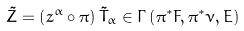<formula> <loc_0><loc_0><loc_500><loc_500>\tilde { Z } = \left ( z ^ { \alpha } \circ \pi \right ) \tilde { T } _ { \alpha } \in \Gamma \left ( \pi ^ { \ast } F , \pi ^ { \ast } \nu , E \right )</formula> 